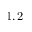Convert formula to latex. <formula><loc_0><loc_0><loc_500><loc_500>1 , 2</formula> 